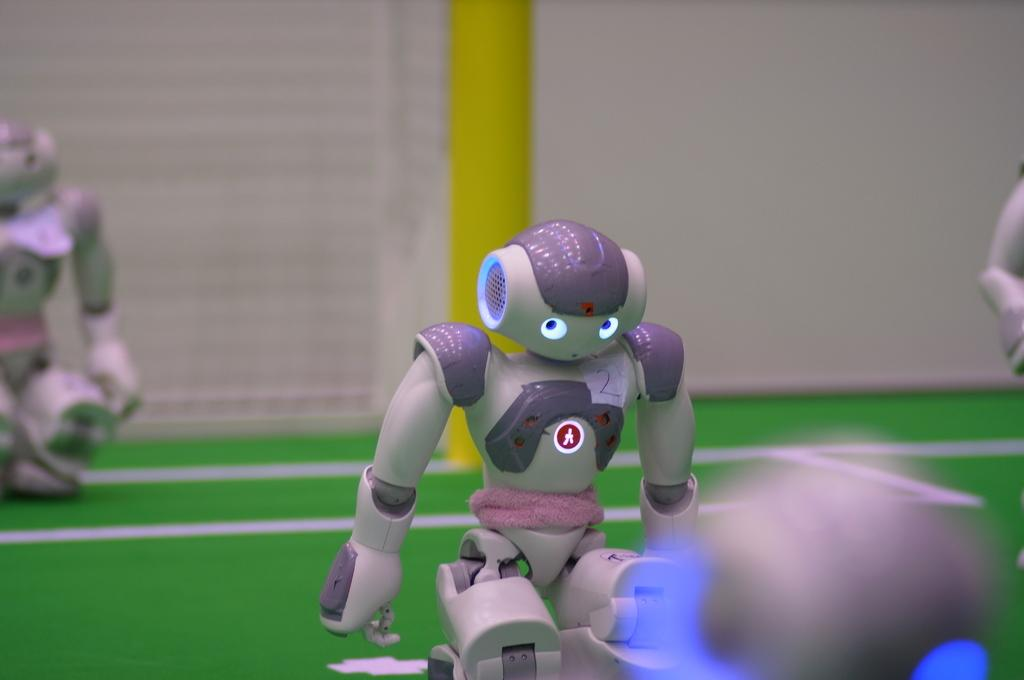What is the main subject in the middle of the image? There is a small robot in the middle of the image. Are there any other robots visible in the image? Yes, there is another robot on the left side of the image. Can you describe the position of the second robot? The second robot is in the background. What can be seen behind the robots? There is a pole behind the robots. What type of yak can be seen sitting on the chair in the image? There is no yak or chair present in the image; it features two robots and a pole. 